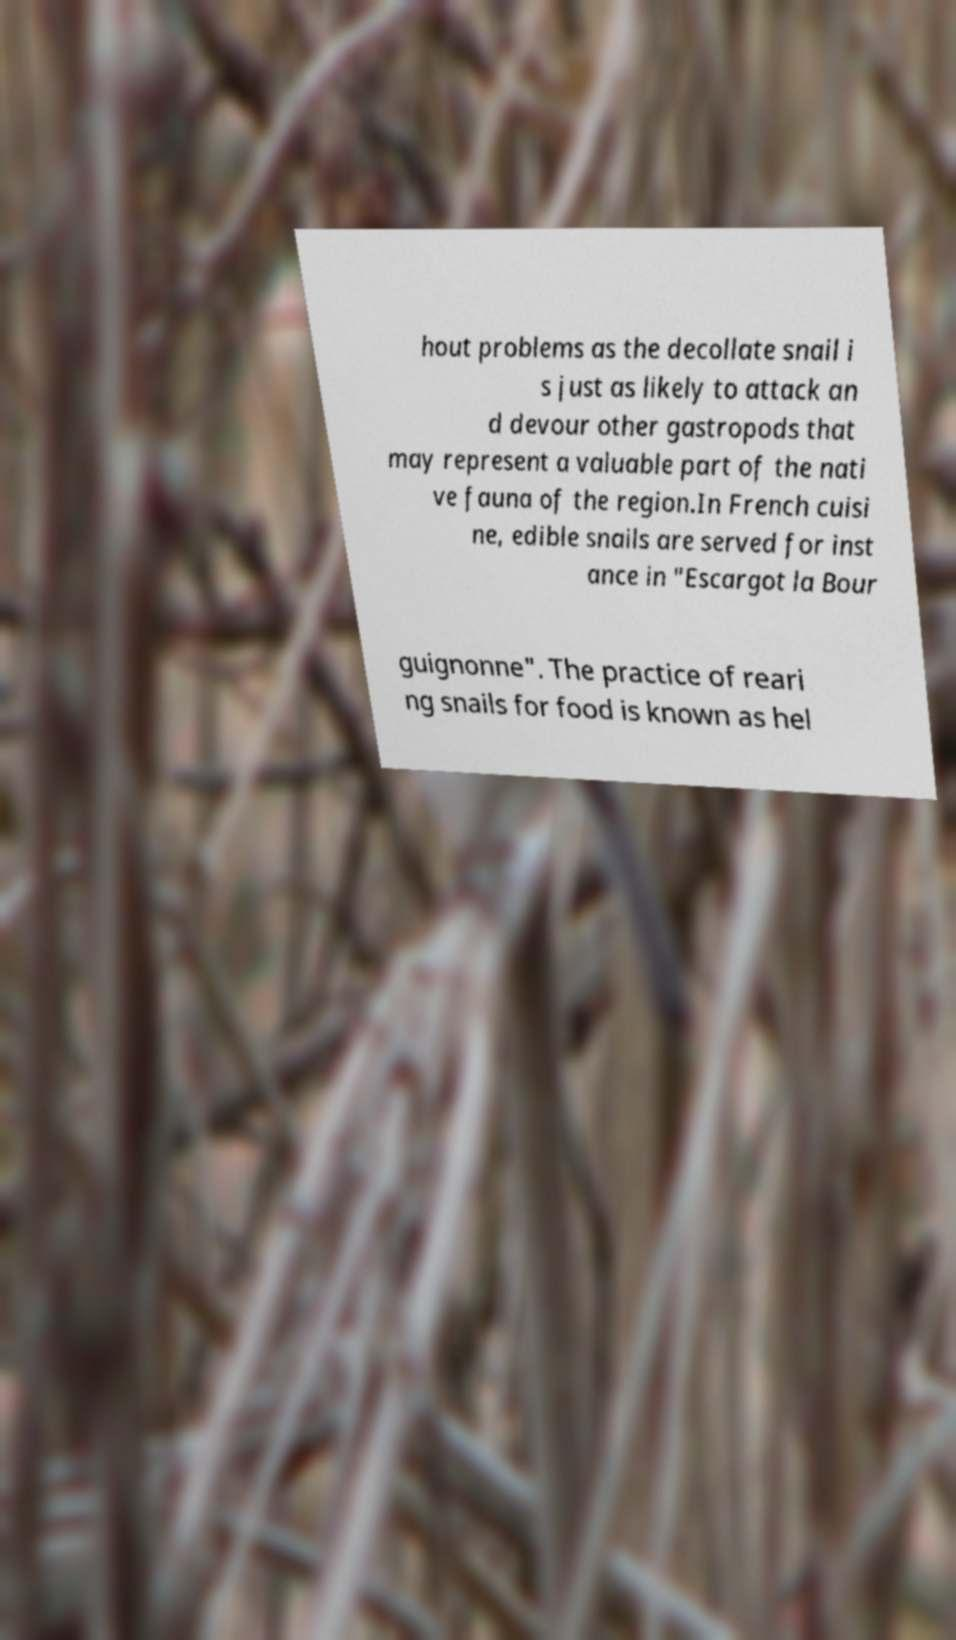Can you accurately transcribe the text from the provided image for me? hout problems as the decollate snail i s just as likely to attack an d devour other gastropods that may represent a valuable part of the nati ve fauna of the region.In French cuisi ne, edible snails are served for inst ance in "Escargot la Bour guignonne". The practice of reari ng snails for food is known as hel 